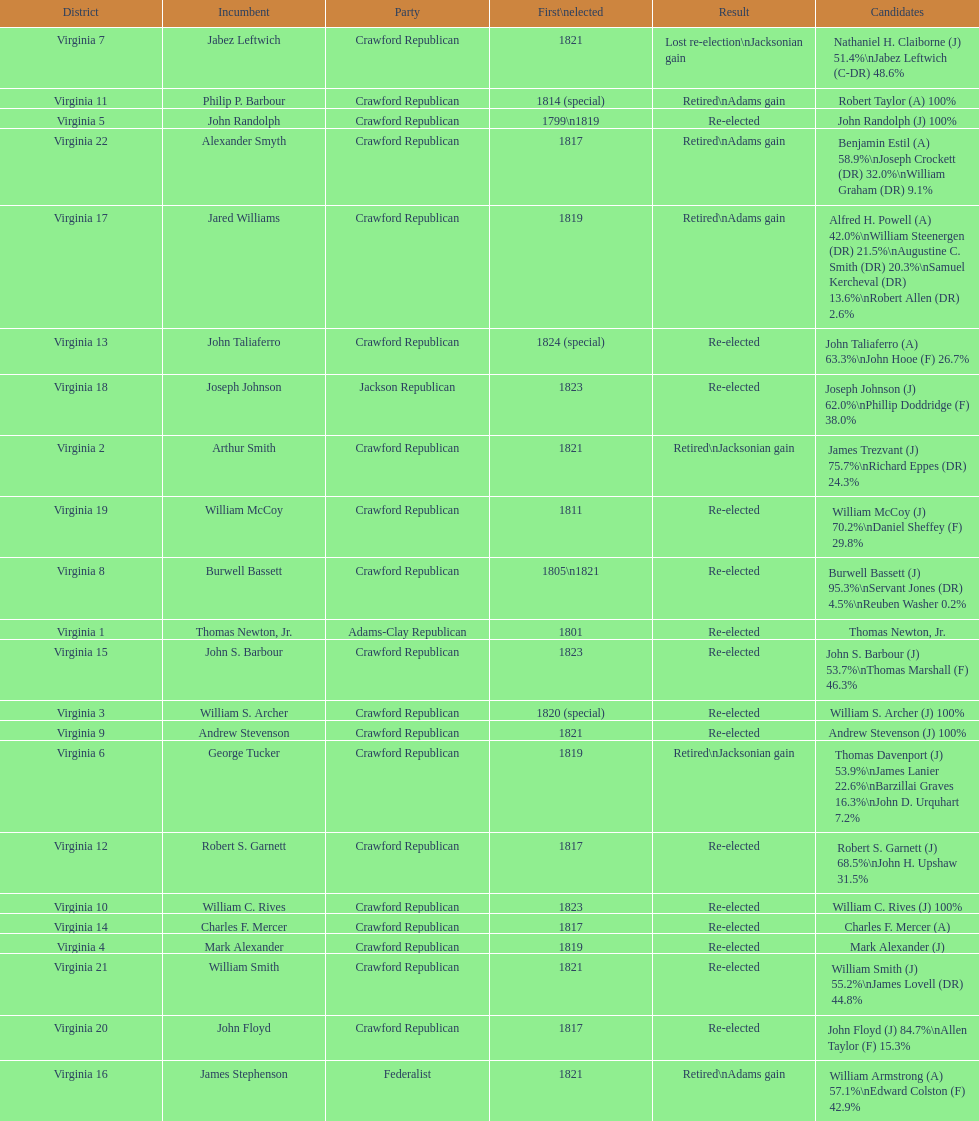Who were the incumbents of the 1824 united states house of representatives elections? Thomas Newton, Jr., Arthur Smith, William S. Archer, Mark Alexander, John Randolph, George Tucker, Jabez Leftwich, Burwell Bassett, Andrew Stevenson, William C. Rives, Philip P. Barbour, Robert S. Garnett, John Taliaferro, Charles F. Mercer, John S. Barbour, James Stephenson, Jared Williams, Joseph Johnson, William McCoy, John Floyd, William Smith, Alexander Smyth. And who were the candidates? Thomas Newton, Jr., James Trezvant (J) 75.7%\nRichard Eppes (DR) 24.3%, William S. Archer (J) 100%, Mark Alexander (J), John Randolph (J) 100%, Thomas Davenport (J) 53.9%\nJames Lanier 22.6%\nBarzillai Graves 16.3%\nJohn D. Urquhart 7.2%, Nathaniel H. Claiborne (J) 51.4%\nJabez Leftwich (C-DR) 48.6%, Burwell Bassett (J) 95.3%\nServant Jones (DR) 4.5%\nReuben Washer 0.2%, Andrew Stevenson (J) 100%, William C. Rives (J) 100%, Robert Taylor (A) 100%, Robert S. Garnett (J) 68.5%\nJohn H. Upshaw 31.5%, John Taliaferro (A) 63.3%\nJohn Hooe (F) 26.7%, Charles F. Mercer (A), John S. Barbour (J) 53.7%\nThomas Marshall (F) 46.3%, William Armstrong (A) 57.1%\nEdward Colston (F) 42.9%, Alfred H. Powell (A) 42.0%\nWilliam Steenergen (DR) 21.5%\nAugustine C. Smith (DR) 20.3%\nSamuel Kercheval (DR) 13.6%\nRobert Allen (DR) 2.6%, Joseph Johnson (J) 62.0%\nPhillip Doddridge (F) 38.0%, William McCoy (J) 70.2%\nDaniel Sheffey (F) 29.8%, John Floyd (J) 84.7%\nAllen Taylor (F) 15.3%, William Smith (J) 55.2%\nJames Lovell (DR) 44.8%, Benjamin Estil (A) 58.9%\nJoseph Crockett (DR) 32.0%\nWilliam Graham (DR) 9.1%. What were the results of their elections? Re-elected, Retired\nJacksonian gain, Re-elected, Re-elected, Re-elected, Retired\nJacksonian gain, Lost re-election\nJacksonian gain, Re-elected, Re-elected, Re-elected, Retired\nAdams gain, Re-elected, Re-elected, Re-elected, Re-elected, Retired\nAdams gain, Retired\nAdams gain, Re-elected, Re-elected, Re-elected, Re-elected, Retired\nAdams gain. And which jacksonian won over 76%? Arthur Smith. 